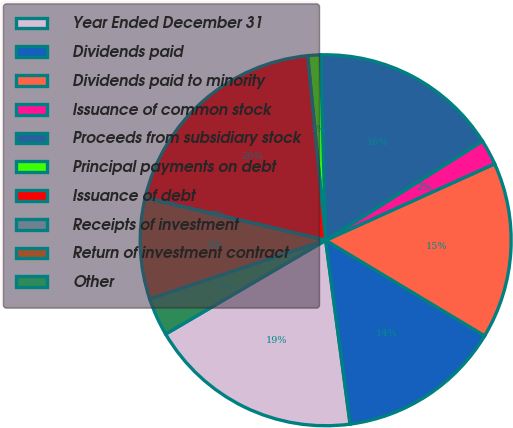Convert chart. <chart><loc_0><loc_0><loc_500><loc_500><pie_chart><fcel>Year Ended December 31<fcel>Dividends paid<fcel>Dividends paid to minority<fcel>Issuance of common stock<fcel>Proceeds from subsidiary stock<fcel>Principal payments on debt<fcel>Issuance of debt<fcel>Receipts of investment<fcel>Return of investment contract<fcel>Other<nl><fcel>18.67%<fcel>14.28%<fcel>15.38%<fcel>2.21%<fcel>16.47%<fcel>1.11%<fcel>19.77%<fcel>0.02%<fcel>8.79%<fcel>3.31%<nl></chart> 